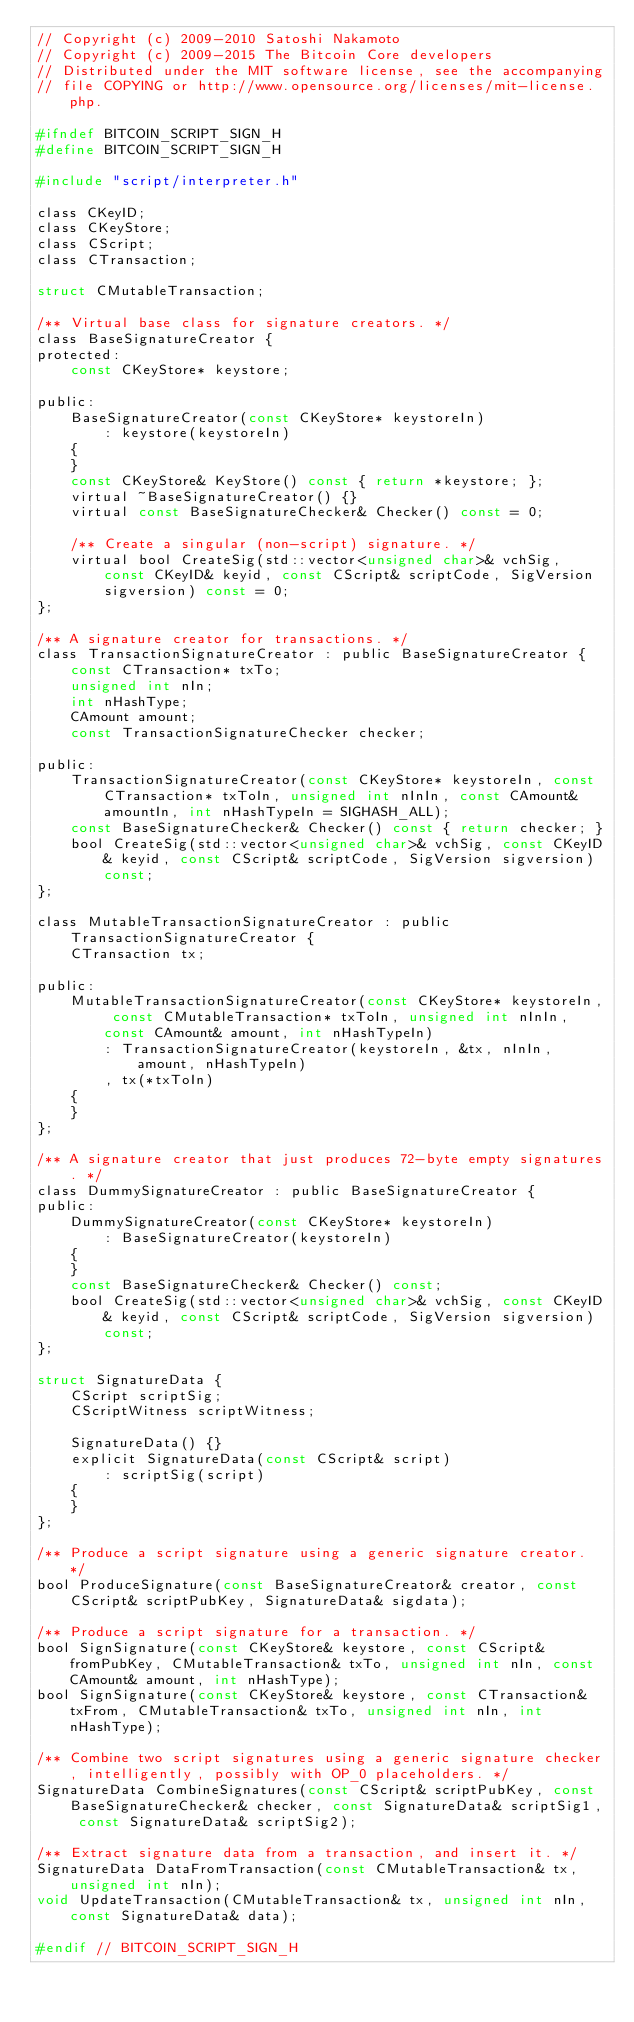Convert code to text. <code><loc_0><loc_0><loc_500><loc_500><_C_>// Copyright (c) 2009-2010 Satoshi Nakamoto
// Copyright (c) 2009-2015 The Bitcoin Core developers
// Distributed under the MIT software license, see the accompanying
// file COPYING or http://www.opensource.org/licenses/mit-license.php.

#ifndef BITCOIN_SCRIPT_SIGN_H
#define BITCOIN_SCRIPT_SIGN_H

#include "script/interpreter.h"

class CKeyID;
class CKeyStore;
class CScript;
class CTransaction;

struct CMutableTransaction;

/** Virtual base class for signature creators. */
class BaseSignatureCreator {
protected:
    const CKeyStore* keystore;

public:
    BaseSignatureCreator(const CKeyStore* keystoreIn)
        : keystore(keystoreIn)
    {
    }
    const CKeyStore& KeyStore() const { return *keystore; };
    virtual ~BaseSignatureCreator() {}
    virtual const BaseSignatureChecker& Checker() const = 0;

    /** Create a singular (non-script) signature. */
    virtual bool CreateSig(std::vector<unsigned char>& vchSig, const CKeyID& keyid, const CScript& scriptCode, SigVersion sigversion) const = 0;
};

/** A signature creator for transactions. */
class TransactionSignatureCreator : public BaseSignatureCreator {
    const CTransaction* txTo;
    unsigned int nIn;
    int nHashType;
    CAmount amount;
    const TransactionSignatureChecker checker;

public:
    TransactionSignatureCreator(const CKeyStore* keystoreIn, const CTransaction* txToIn, unsigned int nInIn, const CAmount& amountIn, int nHashTypeIn = SIGHASH_ALL);
    const BaseSignatureChecker& Checker() const { return checker; }
    bool CreateSig(std::vector<unsigned char>& vchSig, const CKeyID& keyid, const CScript& scriptCode, SigVersion sigversion) const;
};

class MutableTransactionSignatureCreator : public TransactionSignatureCreator {
    CTransaction tx;

public:
    MutableTransactionSignatureCreator(const CKeyStore* keystoreIn, const CMutableTransaction* txToIn, unsigned int nInIn, const CAmount& amount, int nHashTypeIn)
        : TransactionSignatureCreator(keystoreIn, &tx, nInIn, amount, nHashTypeIn)
        , tx(*txToIn)
    {
    }
};

/** A signature creator that just produces 72-byte empty signatures. */
class DummySignatureCreator : public BaseSignatureCreator {
public:
    DummySignatureCreator(const CKeyStore* keystoreIn)
        : BaseSignatureCreator(keystoreIn)
    {
    }
    const BaseSignatureChecker& Checker() const;
    bool CreateSig(std::vector<unsigned char>& vchSig, const CKeyID& keyid, const CScript& scriptCode, SigVersion sigversion) const;
};

struct SignatureData {
    CScript scriptSig;
    CScriptWitness scriptWitness;

    SignatureData() {}
    explicit SignatureData(const CScript& script)
        : scriptSig(script)
    {
    }
};

/** Produce a script signature using a generic signature creator. */
bool ProduceSignature(const BaseSignatureCreator& creator, const CScript& scriptPubKey, SignatureData& sigdata);

/** Produce a script signature for a transaction. */
bool SignSignature(const CKeyStore& keystore, const CScript& fromPubKey, CMutableTransaction& txTo, unsigned int nIn, const CAmount& amount, int nHashType);
bool SignSignature(const CKeyStore& keystore, const CTransaction& txFrom, CMutableTransaction& txTo, unsigned int nIn, int nHashType);

/** Combine two script signatures using a generic signature checker, intelligently, possibly with OP_0 placeholders. */
SignatureData CombineSignatures(const CScript& scriptPubKey, const BaseSignatureChecker& checker, const SignatureData& scriptSig1, const SignatureData& scriptSig2);

/** Extract signature data from a transaction, and insert it. */
SignatureData DataFromTransaction(const CMutableTransaction& tx, unsigned int nIn);
void UpdateTransaction(CMutableTransaction& tx, unsigned int nIn, const SignatureData& data);

#endif // BITCOIN_SCRIPT_SIGN_H
</code> 